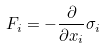<formula> <loc_0><loc_0><loc_500><loc_500>F _ { i } = - \frac { \partial } { \partial x _ { i } } \sigma _ { i }</formula> 